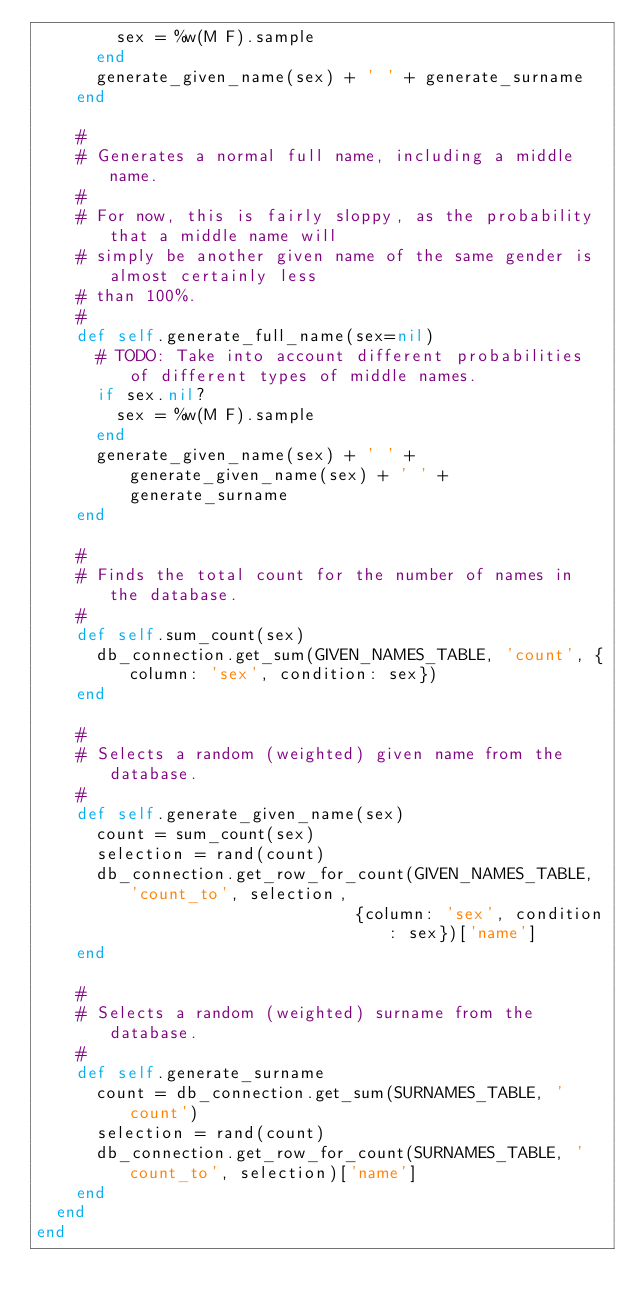<code> <loc_0><loc_0><loc_500><loc_500><_Ruby_>        sex = %w(M F).sample
      end
      generate_given_name(sex) + ' ' + generate_surname
    end

    #
    # Generates a normal full name, including a middle name.
    #
    # For now, this is fairly sloppy, as the probability that a middle name will
    # simply be another given name of the same gender is almost certainly less
    # than 100%.
    #
    def self.generate_full_name(sex=nil)
      # TODO: Take into account different probabilities of different types of middle names.
      if sex.nil?
        sex = %w(M F).sample
      end
      generate_given_name(sex) + ' ' + generate_given_name(sex) + ' ' + generate_surname
    end

    #
    # Finds the total count for the number of names in the database.
    #
    def self.sum_count(sex)
      db_connection.get_sum(GIVEN_NAMES_TABLE, 'count', {column: 'sex', condition: sex})
    end

    #
    # Selects a random (weighted) given name from the database.
    #
    def self.generate_given_name(sex)
      count = sum_count(sex)
      selection = rand(count)
      db_connection.get_row_for_count(GIVEN_NAMES_TABLE, 'count_to', selection,
                                {column: 'sex', condition: sex})['name']
    end

    #
    # Selects a random (weighted) surname from the database.
    #
    def self.generate_surname
      count = db_connection.get_sum(SURNAMES_TABLE, 'count')
      selection = rand(count)
      db_connection.get_row_for_count(SURNAMES_TABLE, 'count_to', selection)['name']
    end
  end
end
</code> 